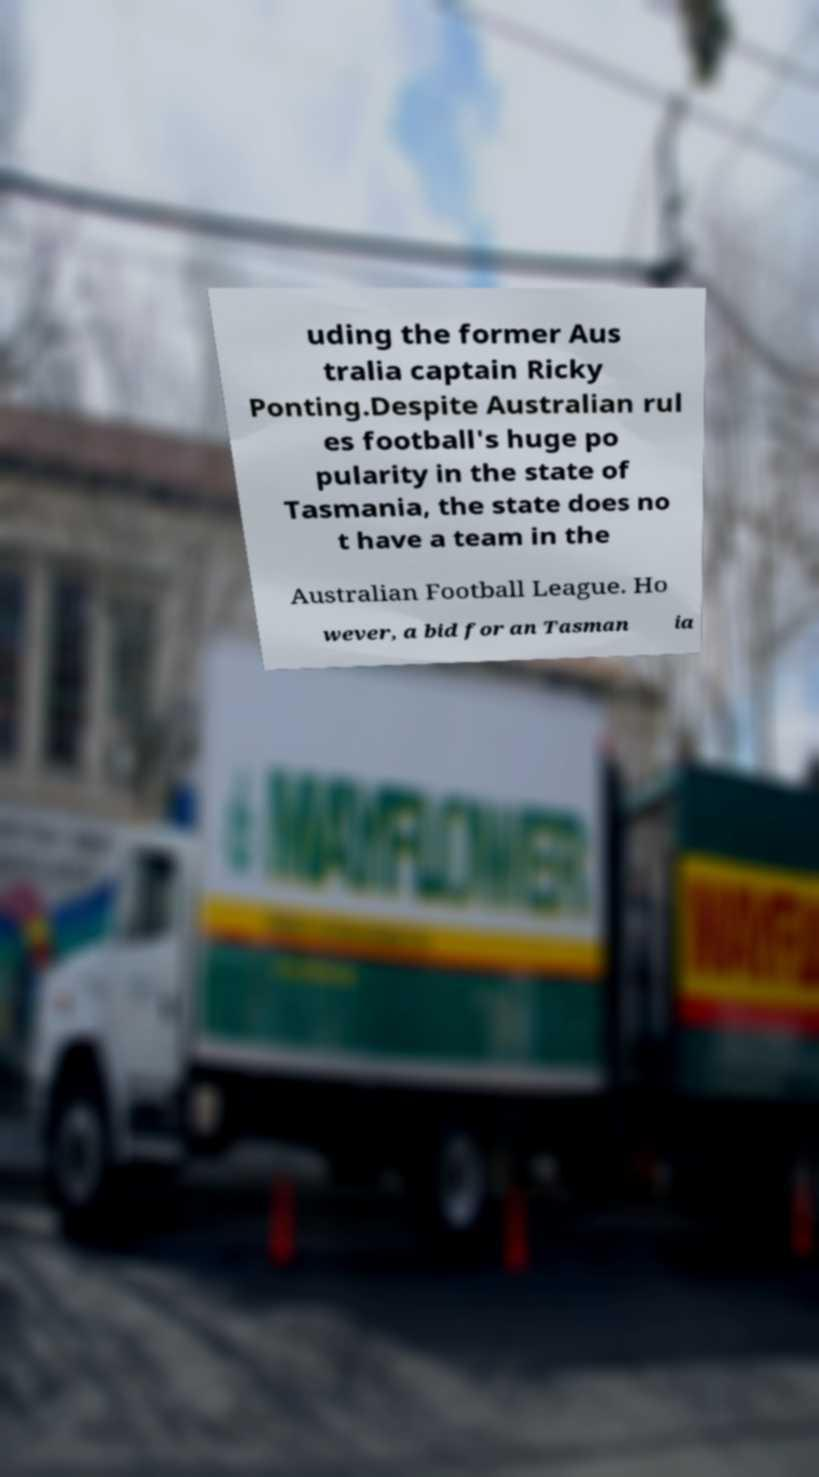Can you read and provide the text displayed in the image?This photo seems to have some interesting text. Can you extract and type it out for me? uding the former Aus tralia captain Ricky Ponting.Despite Australian rul es football's huge po pularity in the state of Tasmania, the state does no t have a team in the Australian Football League. Ho wever, a bid for an Tasman ia 